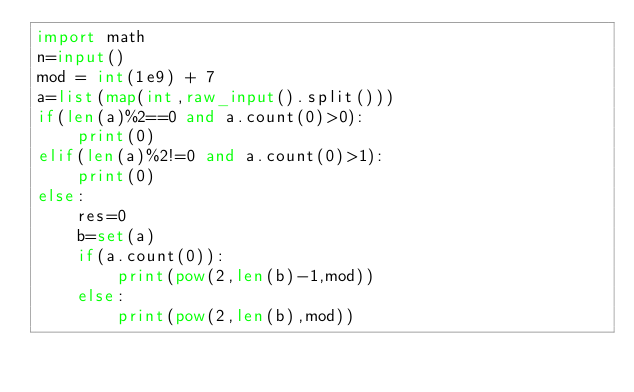Convert code to text. <code><loc_0><loc_0><loc_500><loc_500><_Python_>import math
n=input()
mod = int(1e9) + 7
a=list(map(int,raw_input().split()))
if(len(a)%2==0 and a.count(0)>0):
    print(0)
elif(len(a)%2!=0 and a.count(0)>1):
    print(0)
else:    
    res=0
    b=set(a)
    if(a.count(0)):
        print(pow(2,len(b)-1,mod))
    else:
        print(pow(2,len(b),mod))
        </code> 